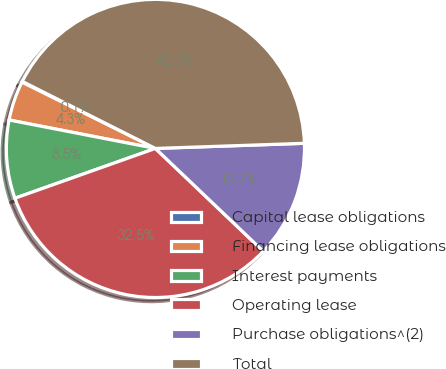<chart> <loc_0><loc_0><loc_500><loc_500><pie_chart><fcel>Capital lease obligations<fcel>Financing lease obligations<fcel>Interest payments<fcel>Operating lease<fcel>Purchase obligations^(2)<fcel>Total<nl><fcel>0.09%<fcel>4.28%<fcel>8.48%<fcel>32.46%<fcel>12.67%<fcel>42.03%<nl></chart> 